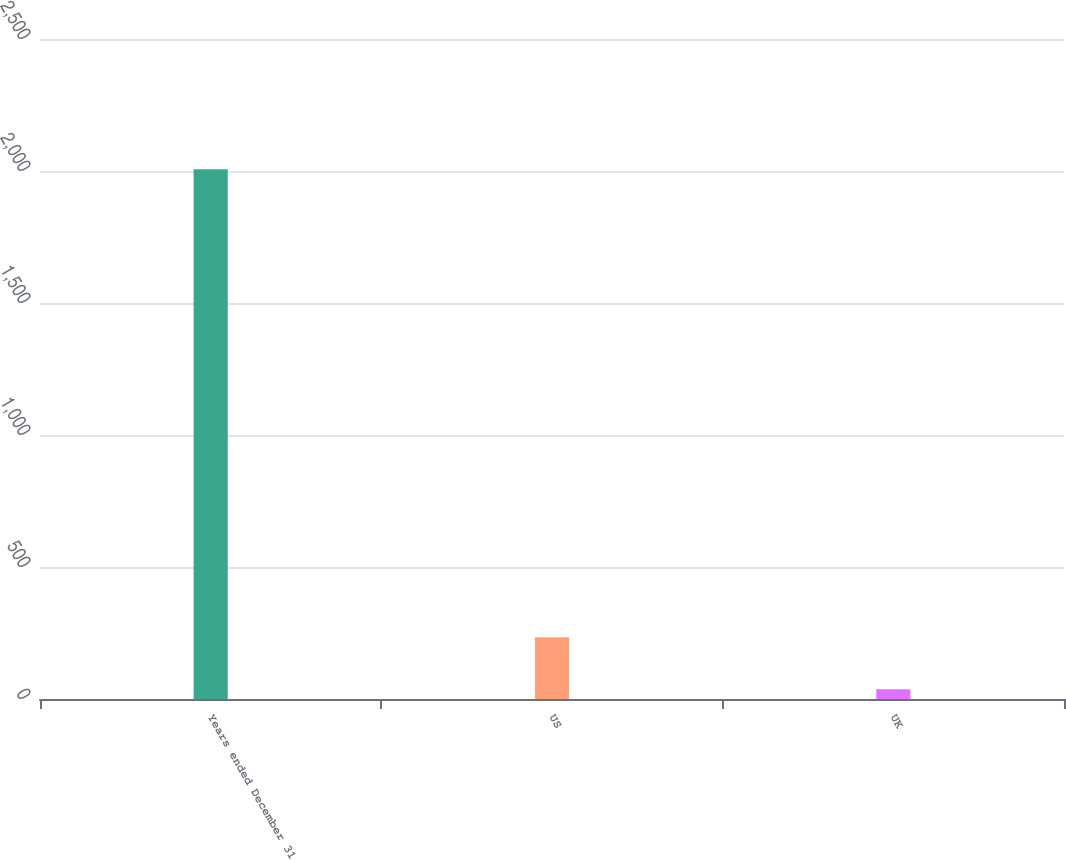<chart> <loc_0><loc_0><loc_500><loc_500><bar_chart><fcel>Years ended December 31<fcel>US<fcel>UK<nl><fcel>2007<fcel>234<fcel>37<nl></chart> 